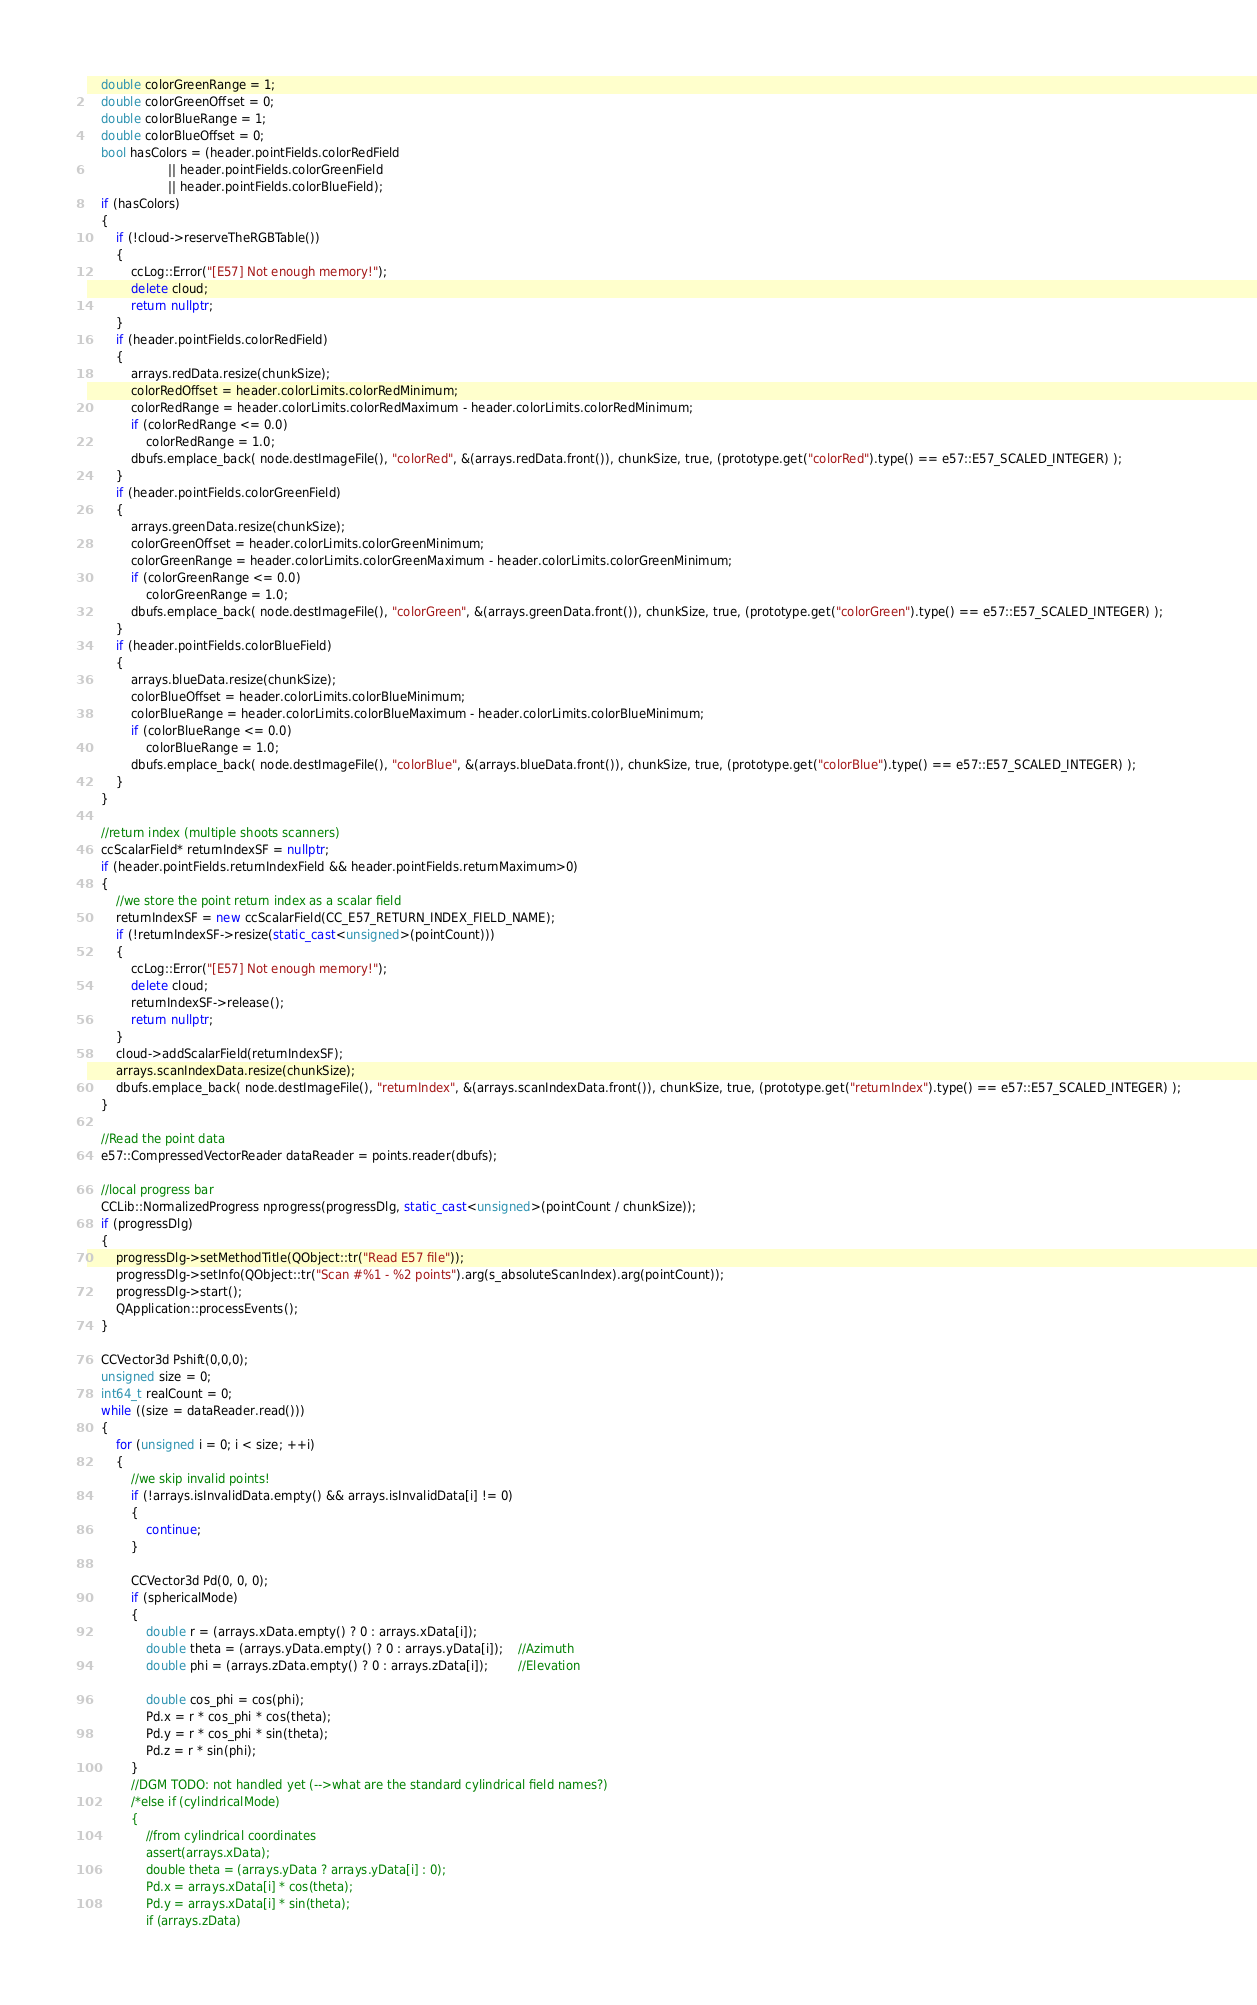<code> <loc_0><loc_0><loc_500><loc_500><_C++_>	double colorGreenRange = 1;
	double colorGreenOffset = 0;
	double colorBlueRange = 1;
	double colorBlueOffset = 0;
	bool hasColors = (header.pointFields.colorRedField
					  || header.pointFields.colorGreenField
					  || header.pointFields.colorBlueField);
	if (hasColors)
	{
		if (!cloud->reserveTheRGBTable())
		{
			ccLog::Error("[E57] Not enough memory!");
			delete cloud;
			return nullptr;
		}
		if (header.pointFields.colorRedField)
		{
			arrays.redData.resize(chunkSize);
			colorRedOffset = header.colorLimits.colorRedMinimum;
			colorRedRange = header.colorLimits.colorRedMaximum - header.colorLimits.colorRedMinimum;
			if (colorRedRange <= 0.0)
				colorRedRange = 1.0;
			dbufs.emplace_back( node.destImageFile(), "colorRed", &(arrays.redData.front()), chunkSize, true, (prototype.get("colorRed").type() == e57::E57_SCALED_INTEGER) );
		}
		if (header.pointFields.colorGreenField)
		{
			arrays.greenData.resize(chunkSize);
			colorGreenOffset = header.colorLimits.colorGreenMinimum;
			colorGreenRange = header.colorLimits.colorGreenMaximum - header.colorLimits.colorGreenMinimum;
			if (colorGreenRange <= 0.0)
				colorGreenRange = 1.0;
			dbufs.emplace_back( node.destImageFile(), "colorGreen", &(arrays.greenData.front()), chunkSize, true, (prototype.get("colorGreen").type() == e57::E57_SCALED_INTEGER) );
		}
		if (header.pointFields.colorBlueField)
		{
			arrays.blueData.resize(chunkSize);
			colorBlueOffset = header.colorLimits.colorBlueMinimum;
			colorBlueRange = header.colorLimits.colorBlueMaximum - header.colorLimits.colorBlueMinimum;
			if (colorBlueRange <= 0.0)
				colorBlueRange = 1.0;
			dbufs.emplace_back( node.destImageFile(), "colorBlue", &(arrays.blueData.front()), chunkSize, true, (prototype.get("colorBlue").type() == e57::E57_SCALED_INTEGER) );
		}
	}

	//return index (multiple shoots scanners)
	ccScalarField* returnIndexSF = nullptr;
	if (header.pointFields.returnIndexField && header.pointFields.returnMaximum>0)
	{
		//we store the point return index as a scalar field
		returnIndexSF = new ccScalarField(CC_E57_RETURN_INDEX_FIELD_NAME);
		if (!returnIndexSF->resize(static_cast<unsigned>(pointCount)))
		{
			ccLog::Error("[E57] Not enough memory!");
			delete cloud;
			returnIndexSF->release();
			return nullptr;
		}
		cloud->addScalarField(returnIndexSF);
		arrays.scanIndexData.resize(chunkSize);
		dbufs.emplace_back( node.destImageFile(), "returnIndex", &(arrays.scanIndexData.front()), chunkSize, true, (prototype.get("returnIndex").type() == e57::E57_SCALED_INTEGER) );
	}

	//Read the point data
	e57::CompressedVectorReader dataReader = points.reader(dbufs);

	//local progress bar
	CCLib::NormalizedProgress nprogress(progressDlg, static_cast<unsigned>(pointCount / chunkSize));
	if (progressDlg)
	{
		progressDlg->setMethodTitle(QObject::tr("Read E57 file"));
		progressDlg->setInfo(QObject::tr("Scan #%1 - %2 points").arg(s_absoluteScanIndex).arg(pointCount));
		progressDlg->start();
		QApplication::processEvents();
	}

	CCVector3d Pshift(0,0,0);
	unsigned size = 0;
	int64_t realCount = 0;
	while ((size = dataReader.read()))
	{
		for (unsigned i = 0; i < size; ++i)
		{
			//we skip invalid points!
			if (!arrays.isInvalidData.empty() && arrays.isInvalidData[i] != 0)
			{
				continue;
			}

			CCVector3d Pd(0, 0, 0);
			if (sphericalMode)
			{
				double r = (arrays.xData.empty() ? 0 : arrays.xData[i]);
				double theta = (arrays.yData.empty() ? 0 : arrays.yData[i]);	//Azimuth
				double phi = (arrays.zData.empty() ? 0 : arrays.zData[i]);		//Elevation

				double cos_phi = cos(phi);
				Pd.x = r * cos_phi * cos(theta);
				Pd.y = r * cos_phi * sin(theta);
				Pd.z = r * sin(phi);
			}
			//DGM TODO: not handled yet (-->what are the standard cylindrical field names?)
			/*else if (cylindricalMode)
			{
				//from cylindrical coordinates
				assert(arrays.xData);
				double theta = (arrays.yData ? arrays.yData[i] : 0);
				Pd.x = arrays.xData[i] * cos(theta);
				Pd.y = arrays.xData[i] * sin(theta);
				if (arrays.zData)</code> 